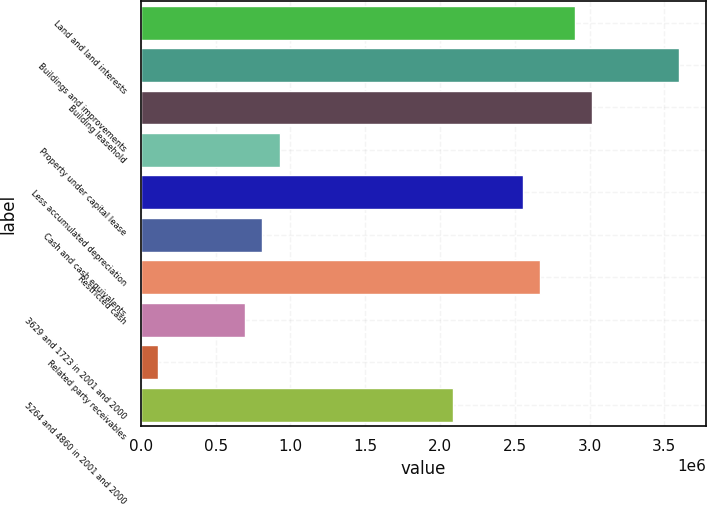Convert chart. <chart><loc_0><loc_0><loc_500><loc_500><bar_chart><fcel>Land and land interests<fcel>Buildings and improvements<fcel>Building leasehold<fcel>Property under capital lease<fcel>Less accumulated depreciation<fcel>Cash and cash equivalents<fcel>Restricted cash<fcel>3629 and 1723 in 2001 and 2000<fcel>Related party receivables<fcel>5264 and 4860 in 2001 and 2000<nl><fcel>2.90252e+06<fcel>3.59906e+06<fcel>3.01861e+06<fcel>928972<fcel>2.55424e+06<fcel>812882<fcel>2.67033e+06<fcel>696791<fcel>116337<fcel>2.08988e+06<nl></chart> 